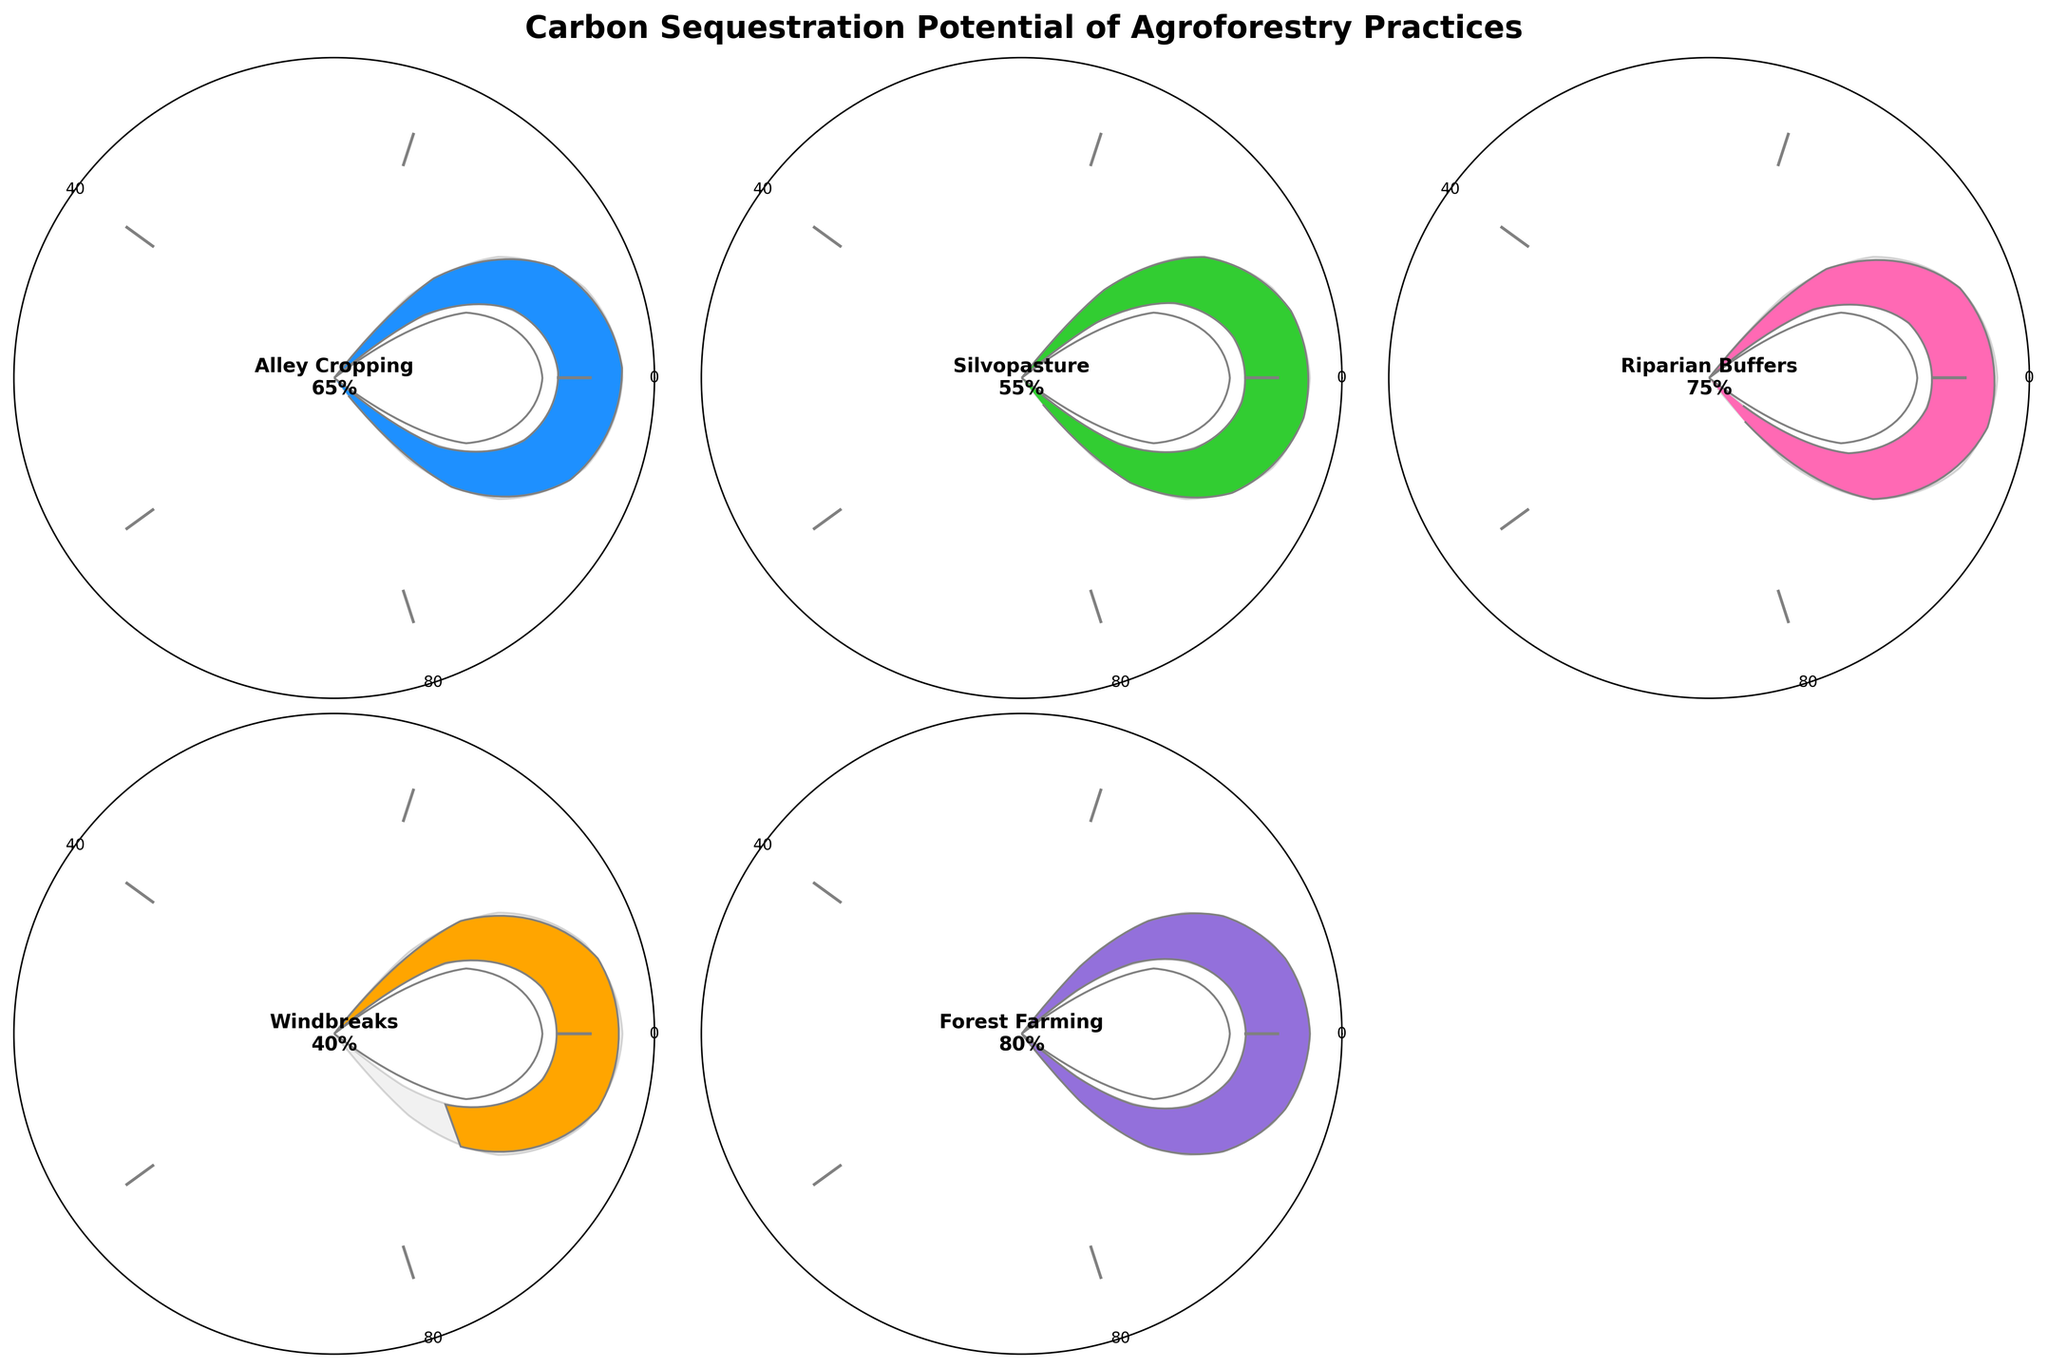what is the highest carbon sequestration potential among the agroforestry practices? The practice with the highest carbon sequestration potential is the one with the largest value displayed on the gauge chart. Forest Farming has the highest percentage, which is 80%.
Answer: 80% how many agroforestry practices are depicted in the figure? Count the number of unique practices represented by individual gauge charts. There are five practices shown: Alley Cropping, Silvopasture, Riparian Buffers, Windbreaks, and Forest Farming.
Answer: 5 which agroforestry practice has the lowest carbon sequestration potential? Identify the practice with the smallest value on the gauge chart. Windbreaks have the lowest percentage, which is 40%.
Answer: 40% what is the difference in carbon sequestration potential between Riparian Buffers and Silvopasture? Subtract Silvopasture's value from Riparian Buffers' value: 75% - 55% = 20%.
Answer: 20% are there any practices with a carbon sequestration potential of 60% or greater? Identify all practices with values equal to or greater than 60%. Alley Cropping (65%), Riparian Buffers (75%), and Forest Farming (80%) all meet this criterion.
Answer: Yes which of the agroforestry practices fall below the median value of the provided carbon sequestration potentials? List the values, identify the middle value when sorted: [40, 55, 65, 75, 80]. The median is 65%. Practices below this are Windbreaks (40%) and Silvopasture (55%).
Answer: Windbreaks, Silvopasture what is the average carbon sequestration potential of all the agroforestry practices? Sum all the values and divide by the number of practices: (65 + 55 + 75 + 40 + 80) / 5 = 63%.
Answer: 63% by how much does Forest Farming exceed Windbreaks in carbon sequestration potential? Subtract Windbreaks' value from Forest Farming's value: 80% - 40% = 40%.
Answer: 40% which agroforestry practice is closest in carbon sequestration potential to Alley Cropping? Identify the practice whose value is numerically closest to Alley Cropping's value of 65%. Silvopasture is the closest with a value of 55% (a difference of 10%).
Answer: Silvopasture 